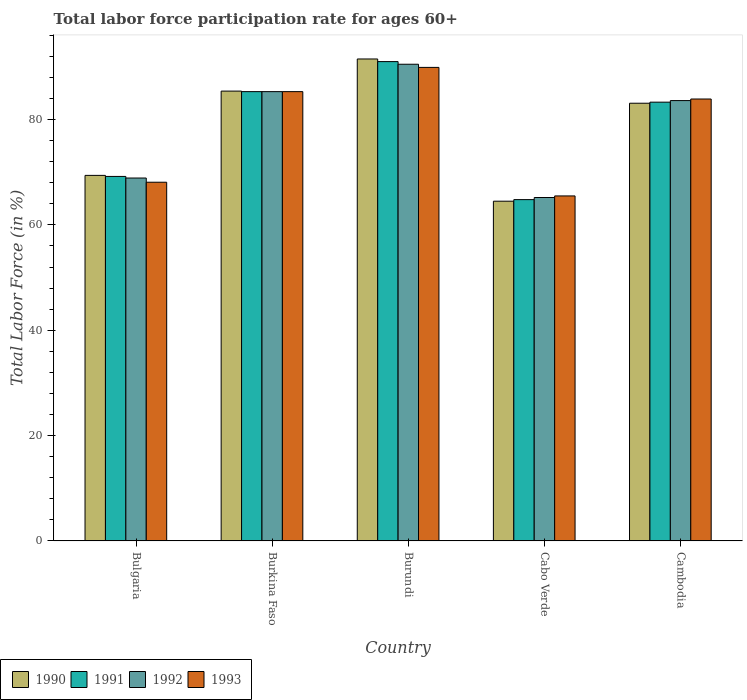How many different coloured bars are there?
Your response must be concise. 4. Are the number of bars per tick equal to the number of legend labels?
Offer a very short reply. Yes. What is the labor force participation rate in 1990 in Burundi?
Make the answer very short. 91.5. Across all countries, what is the maximum labor force participation rate in 1990?
Provide a succinct answer. 91.5. Across all countries, what is the minimum labor force participation rate in 1991?
Keep it short and to the point. 64.8. In which country was the labor force participation rate in 1991 maximum?
Your answer should be very brief. Burundi. In which country was the labor force participation rate in 1992 minimum?
Your answer should be very brief. Cabo Verde. What is the total labor force participation rate in 1992 in the graph?
Provide a short and direct response. 393.5. What is the difference between the labor force participation rate in 1993 in Bulgaria and that in Cambodia?
Provide a succinct answer. -15.8. What is the difference between the labor force participation rate in 1993 in Burkina Faso and the labor force participation rate in 1992 in Bulgaria?
Make the answer very short. 16.4. What is the average labor force participation rate in 1990 per country?
Offer a very short reply. 78.78. What is the difference between the labor force participation rate of/in 1992 and labor force participation rate of/in 1991 in Cabo Verde?
Your answer should be compact. 0.4. What is the ratio of the labor force participation rate in 1990 in Bulgaria to that in Cabo Verde?
Provide a succinct answer. 1.08. Is the labor force participation rate in 1993 in Burundi less than that in Cambodia?
Give a very brief answer. No. What is the difference between the highest and the second highest labor force participation rate in 1992?
Your answer should be compact. 6.9. What is the difference between the highest and the lowest labor force participation rate in 1991?
Provide a short and direct response. 26.2. In how many countries, is the labor force participation rate in 1990 greater than the average labor force participation rate in 1990 taken over all countries?
Your answer should be compact. 3. Is the sum of the labor force participation rate in 1993 in Burundi and Cabo Verde greater than the maximum labor force participation rate in 1990 across all countries?
Offer a terse response. Yes. Is it the case that in every country, the sum of the labor force participation rate in 1992 and labor force participation rate in 1993 is greater than the sum of labor force participation rate in 1990 and labor force participation rate in 1991?
Give a very brief answer. No. What does the 1st bar from the left in Burkina Faso represents?
Keep it short and to the point. 1990. What does the 1st bar from the right in Burundi represents?
Keep it short and to the point. 1993. Are all the bars in the graph horizontal?
Offer a terse response. No. What is the difference between two consecutive major ticks on the Y-axis?
Provide a succinct answer. 20. Does the graph contain any zero values?
Offer a very short reply. No. How many legend labels are there?
Give a very brief answer. 4. How are the legend labels stacked?
Your answer should be very brief. Horizontal. What is the title of the graph?
Provide a short and direct response. Total labor force participation rate for ages 60+. What is the label or title of the Y-axis?
Provide a short and direct response. Total Labor Force (in %). What is the Total Labor Force (in %) in 1990 in Bulgaria?
Provide a succinct answer. 69.4. What is the Total Labor Force (in %) of 1991 in Bulgaria?
Your answer should be very brief. 69.2. What is the Total Labor Force (in %) of 1992 in Bulgaria?
Make the answer very short. 68.9. What is the Total Labor Force (in %) in 1993 in Bulgaria?
Provide a short and direct response. 68.1. What is the Total Labor Force (in %) in 1990 in Burkina Faso?
Your answer should be very brief. 85.4. What is the Total Labor Force (in %) of 1991 in Burkina Faso?
Offer a terse response. 85.3. What is the Total Labor Force (in %) in 1992 in Burkina Faso?
Provide a succinct answer. 85.3. What is the Total Labor Force (in %) of 1993 in Burkina Faso?
Provide a short and direct response. 85.3. What is the Total Labor Force (in %) of 1990 in Burundi?
Provide a succinct answer. 91.5. What is the Total Labor Force (in %) in 1991 in Burundi?
Offer a terse response. 91. What is the Total Labor Force (in %) of 1992 in Burundi?
Keep it short and to the point. 90.5. What is the Total Labor Force (in %) in 1993 in Burundi?
Provide a short and direct response. 89.9. What is the Total Labor Force (in %) in 1990 in Cabo Verde?
Your response must be concise. 64.5. What is the Total Labor Force (in %) in 1991 in Cabo Verde?
Your response must be concise. 64.8. What is the Total Labor Force (in %) in 1992 in Cabo Verde?
Ensure brevity in your answer.  65.2. What is the Total Labor Force (in %) of 1993 in Cabo Verde?
Offer a terse response. 65.5. What is the Total Labor Force (in %) of 1990 in Cambodia?
Ensure brevity in your answer.  83.1. What is the Total Labor Force (in %) of 1991 in Cambodia?
Your answer should be very brief. 83.3. What is the Total Labor Force (in %) of 1992 in Cambodia?
Your response must be concise. 83.6. What is the Total Labor Force (in %) in 1993 in Cambodia?
Your response must be concise. 83.9. Across all countries, what is the maximum Total Labor Force (in %) in 1990?
Keep it short and to the point. 91.5. Across all countries, what is the maximum Total Labor Force (in %) of 1991?
Make the answer very short. 91. Across all countries, what is the maximum Total Labor Force (in %) in 1992?
Make the answer very short. 90.5. Across all countries, what is the maximum Total Labor Force (in %) in 1993?
Ensure brevity in your answer.  89.9. Across all countries, what is the minimum Total Labor Force (in %) of 1990?
Keep it short and to the point. 64.5. Across all countries, what is the minimum Total Labor Force (in %) of 1991?
Provide a succinct answer. 64.8. Across all countries, what is the minimum Total Labor Force (in %) in 1992?
Offer a very short reply. 65.2. Across all countries, what is the minimum Total Labor Force (in %) of 1993?
Offer a very short reply. 65.5. What is the total Total Labor Force (in %) in 1990 in the graph?
Provide a short and direct response. 393.9. What is the total Total Labor Force (in %) of 1991 in the graph?
Keep it short and to the point. 393.6. What is the total Total Labor Force (in %) of 1992 in the graph?
Your answer should be very brief. 393.5. What is the total Total Labor Force (in %) in 1993 in the graph?
Provide a short and direct response. 392.7. What is the difference between the Total Labor Force (in %) of 1991 in Bulgaria and that in Burkina Faso?
Your answer should be compact. -16.1. What is the difference between the Total Labor Force (in %) of 1992 in Bulgaria and that in Burkina Faso?
Ensure brevity in your answer.  -16.4. What is the difference between the Total Labor Force (in %) in 1993 in Bulgaria and that in Burkina Faso?
Your answer should be compact. -17.2. What is the difference between the Total Labor Force (in %) of 1990 in Bulgaria and that in Burundi?
Your answer should be very brief. -22.1. What is the difference between the Total Labor Force (in %) of 1991 in Bulgaria and that in Burundi?
Provide a short and direct response. -21.8. What is the difference between the Total Labor Force (in %) in 1992 in Bulgaria and that in Burundi?
Ensure brevity in your answer.  -21.6. What is the difference between the Total Labor Force (in %) of 1993 in Bulgaria and that in Burundi?
Make the answer very short. -21.8. What is the difference between the Total Labor Force (in %) of 1991 in Bulgaria and that in Cabo Verde?
Offer a terse response. 4.4. What is the difference between the Total Labor Force (in %) in 1992 in Bulgaria and that in Cabo Verde?
Give a very brief answer. 3.7. What is the difference between the Total Labor Force (in %) in 1990 in Bulgaria and that in Cambodia?
Keep it short and to the point. -13.7. What is the difference between the Total Labor Force (in %) in 1991 in Bulgaria and that in Cambodia?
Provide a succinct answer. -14.1. What is the difference between the Total Labor Force (in %) in 1992 in Bulgaria and that in Cambodia?
Provide a short and direct response. -14.7. What is the difference between the Total Labor Force (in %) in 1993 in Bulgaria and that in Cambodia?
Ensure brevity in your answer.  -15.8. What is the difference between the Total Labor Force (in %) of 1992 in Burkina Faso and that in Burundi?
Offer a very short reply. -5.2. What is the difference between the Total Labor Force (in %) of 1990 in Burkina Faso and that in Cabo Verde?
Your answer should be compact. 20.9. What is the difference between the Total Labor Force (in %) in 1991 in Burkina Faso and that in Cabo Verde?
Your answer should be compact. 20.5. What is the difference between the Total Labor Force (in %) of 1992 in Burkina Faso and that in Cabo Verde?
Your response must be concise. 20.1. What is the difference between the Total Labor Force (in %) of 1993 in Burkina Faso and that in Cabo Verde?
Your answer should be compact. 19.8. What is the difference between the Total Labor Force (in %) in 1990 in Burkina Faso and that in Cambodia?
Your answer should be very brief. 2.3. What is the difference between the Total Labor Force (in %) of 1992 in Burkina Faso and that in Cambodia?
Give a very brief answer. 1.7. What is the difference between the Total Labor Force (in %) of 1991 in Burundi and that in Cabo Verde?
Ensure brevity in your answer.  26.2. What is the difference between the Total Labor Force (in %) in 1992 in Burundi and that in Cabo Verde?
Keep it short and to the point. 25.3. What is the difference between the Total Labor Force (in %) in 1993 in Burundi and that in Cabo Verde?
Provide a short and direct response. 24.4. What is the difference between the Total Labor Force (in %) of 1990 in Burundi and that in Cambodia?
Your answer should be very brief. 8.4. What is the difference between the Total Labor Force (in %) of 1991 in Burundi and that in Cambodia?
Give a very brief answer. 7.7. What is the difference between the Total Labor Force (in %) in 1990 in Cabo Verde and that in Cambodia?
Provide a succinct answer. -18.6. What is the difference between the Total Labor Force (in %) in 1991 in Cabo Verde and that in Cambodia?
Provide a short and direct response. -18.5. What is the difference between the Total Labor Force (in %) in 1992 in Cabo Verde and that in Cambodia?
Offer a very short reply. -18.4. What is the difference between the Total Labor Force (in %) in 1993 in Cabo Verde and that in Cambodia?
Make the answer very short. -18.4. What is the difference between the Total Labor Force (in %) of 1990 in Bulgaria and the Total Labor Force (in %) of 1991 in Burkina Faso?
Offer a terse response. -15.9. What is the difference between the Total Labor Force (in %) in 1990 in Bulgaria and the Total Labor Force (in %) in 1992 in Burkina Faso?
Make the answer very short. -15.9. What is the difference between the Total Labor Force (in %) of 1990 in Bulgaria and the Total Labor Force (in %) of 1993 in Burkina Faso?
Provide a succinct answer. -15.9. What is the difference between the Total Labor Force (in %) in 1991 in Bulgaria and the Total Labor Force (in %) in 1992 in Burkina Faso?
Make the answer very short. -16.1. What is the difference between the Total Labor Force (in %) in 1991 in Bulgaria and the Total Labor Force (in %) in 1993 in Burkina Faso?
Provide a succinct answer. -16.1. What is the difference between the Total Labor Force (in %) in 1992 in Bulgaria and the Total Labor Force (in %) in 1993 in Burkina Faso?
Keep it short and to the point. -16.4. What is the difference between the Total Labor Force (in %) in 1990 in Bulgaria and the Total Labor Force (in %) in 1991 in Burundi?
Keep it short and to the point. -21.6. What is the difference between the Total Labor Force (in %) of 1990 in Bulgaria and the Total Labor Force (in %) of 1992 in Burundi?
Offer a very short reply. -21.1. What is the difference between the Total Labor Force (in %) in 1990 in Bulgaria and the Total Labor Force (in %) in 1993 in Burundi?
Provide a short and direct response. -20.5. What is the difference between the Total Labor Force (in %) of 1991 in Bulgaria and the Total Labor Force (in %) of 1992 in Burundi?
Ensure brevity in your answer.  -21.3. What is the difference between the Total Labor Force (in %) of 1991 in Bulgaria and the Total Labor Force (in %) of 1993 in Burundi?
Ensure brevity in your answer.  -20.7. What is the difference between the Total Labor Force (in %) in 1990 in Bulgaria and the Total Labor Force (in %) in 1991 in Cabo Verde?
Your answer should be compact. 4.6. What is the difference between the Total Labor Force (in %) in 1990 in Bulgaria and the Total Labor Force (in %) in 1992 in Cabo Verde?
Your answer should be compact. 4.2. What is the difference between the Total Labor Force (in %) of 1991 in Bulgaria and the Total Labor Force (in %) of 1992 in Cabo Verde?
Give a very brief answer. 4. What is the difference between the Total Labor Force (in %) of 1991 in Bulgaria and the Total Labor Force (in %) of 1993 in Cabo Verde?
Offer a very short reply. 3.7. What is the difference between the Total Labor Force (in %) of 1991 in Bulgaria and the Total Labor Force (in %) of 1992 in Cambodia?
Make the answer very short. -14.4. What is the difference between the Total Labor Force (in %) in 1991 in Bulgaria and the Total Labor Force (in %) in 1993 in Cambodia?
Provide a short and direct response. -14.7. What is the difference between the Total Labor Force (in %) of 1990 in Burkina Faso and the Total Labor Force (in %) of 1992 in Burundi?
Your answer should be very brief. -5.1. What is the difference between the Total Labor Force (in %) of 1990 in Burkina Faso and the Total Labor Force (in %) of 1991 in Cabo Verde?
Keep it short and to the point. 20.6. What is the difference between the Total Labor Force (in %) of 1990 in Burkina Faso and the Total Labor Force (in %) of 1992 in Cabo Verde?
Ensure brevity in your answer.  20.2. What is the difference between the Total Labor Force (in %) in 1990 in Burkina Faso and the Total Labor Force (in %) in 1993 in Cabo Verde?
Your response must be concise. 19.9. What is the difference between the Total Labor Force (in %) of 1991 in Burkina Faso and the Total Labor Force (in %) of 1992 in Cabo Verde?
Provide a succinct answer. 20.1. What is the difference between the Total Labor Force (in %) of 1991 in Burkina Faso and the Total Labor Force (in %) of 1993 in Cabo Verde?
Your response must be concise. 19.8. What is the difference between the Total Labor Force (in %) in 1992 in Burkina Faso and the Total Labor Force (in %) in 1993 in Cabo Verde?
Make the answer very short. 19.8. What is the difference between the Total Labor Force (in %) of 1990 in Burkina Faso and the Total Labor Force (in %) of 1991 in Cambodia?
Your answer should be compact. 2.1. What is the difference between the Total Labor Force (in %) in 1990 in Burkina Faso and the Total Labor Force (in %) in 1993 in Cambodia?
Keep it short and to the point. 1.5. What is the difference between the Total Labor Force (in %) of 1991 in Burkina Faso and the Total Labor Force (in %) of 1992 in Cambodia?
Offer a terse response. 1.7. What is the difference between the Total Labor Force (in %) in 1990 in Burundi and the Total Labor Force (in %) in 1991 in Cabo Verde?
Ensure brevity in your answer.  26.7. What is the difference between the Total Labor Force (in %) in 1990 in Burundi and the Total Labor Force (in %) in 1992 in Cabo Verde?
Make the answer very short. 26.3. What is the difference between the Total Labor Force (in %) in 1990 in Burundi and the Total Labor Force (in %) in 1993 in Cabo Verde?
Provide a succinct answer. 26. What is the difference between the Total Labor Force (in %) of 1991 in Burundi and the Total Labor Force (in %) of 1992 in Cabo Verde?
Provide a short and direct response. 25.8. What is the difference between the Total Labor Force (in %) in 1992 in Burundi and the Total Labor Force (in %) in 1993 in Cabo Verde?
Your answer should be compact. 25. What is the difference between the Total Labor Force (in %) in 1990 in Burundi and the Total Labor Force (in %) in 1991 in Cambodia?
Offer a terse response. 8.2. What is the difference between the Total Labor Force (in %) of 1990 in Burundi and the Total Labor Force (in %) of 1992 in Cambodia?
Offer a very short reply. 7.9. What is the difference between the Total Labor Force (in %) of 1991 in Burundi and the Total Labor Force (in %) of 1993 in Cambodia?
Offer a terse response. 7.1. What is the difference between the Total Labor Force (in %) in 1992 in Burundi and the Total Labor Force (in %) in 1993 in Cambodia?
Your answer should be very brief. 6.6. What is the difference between the Total Labor Force (in %) in 1990 in Cabo Verde and the Total Labor Force (in %) in 1991 in Cambodia?
Offer a very short reply. -18.8. What is the difference between the Total Labor Force (in %) of 1990 in Cabo Verde and the Total Labor Force (in %) of 1992 in Cambodia?
Keep it short and to the point. -19.1. What is the difference between the Total Labor Force (in %) in 1990 in Cabo Verde and the Total Labor Force (in %) in 1993 in Cambodia?
Your answer should be very brief. -19.4. What is the difference between the Total Labor Force (in %) of 1991 in Cabo Verde and the Total Labor Force (in %) of 1992 in Cambodia?
Your answer should be compact. -18.8. What is the difference between the Total Labor Force (in %) in 1991 in Cabo Verde and the Total Labor Force (in %) in 1993 in Cambodia?
Give a very brief answer. -19.1. What is the difference between the Total Labor Force (in %) in 1992 in Cabo Verde and the Total Labor Force (in %) in 1993 in Cambodia?
Your answer should be very brief. -18.7. What is the average Total Labor Force (in %) in 1990 per country?
Your answer should be compact. 78.78. What is the average Total Labor Force (in %) in 1991 per country?
Your answer should be compact. 78.72. What is the average Total Labor Force (in %) in 1992 per country?
Your answer should be compact. 78.7. What is the average Total Labor Force (in %) in 1993 per country?
Your response must be concise. 78.54. What is the difference between the Total Labor Force (in %) of 1990 and Total Labor Force (in %) of 1993 in Bulgaria?
Make the answer very short. 1.3. What is the difference between the Total Labor Force (in %) in 1991 and Total Labor Force (in %) in 1992 in Bulgaria?
Your response must be concise. 0.3. What is the difference between the Total Labor Force (in %) of 1991 and Total Labor Force (in %) of 1992 in Burkina Faso?
Ensure brevity in your answer.  0. What is the difference between the Total Labor Force (in %) in 1990 and Total Labor Force (in %) in 1991 in Burundi?
Ensure brevity in your answer.  0.5. What is the difference between the Total Labor Force (in %) of 1990 and Total Labor Force (in %) of 1993 in Burundi?
Offer a very short reply. 1.6. What is the difference between the Total Labor Force (in %) in 1990 and Total Labor Force (in %) in 1991 in Cabo Verde?
Give a very brief answer. -0.3. What is the difference between the Total Labor Force (in %) of 1990 and Total Labor Force (in %) of 1993 in Cabo Verde?
Your response must be concise. -1. What is the difference between the Total Labor Force (in %) of 1990 and Total Labor Force (in %) of 1991 in Cambodia?
Your response must be concise. -0.2. What is the difference between the Total Labor Force (in %) in 1991 and Total Labor Force (in %) in 1993 in Cambodia?
Offer a very short reply. -0.6. What is the ratio of the Total Labor Force (in %) of 1990 in Bulgaria to that in Burkina Faso?
Make the answer very short. 0.81. What is the ratio of the Total Labor Force (in %) in 1991 in Bulgaria to that in Burkina Faso?
Your response must be concise. 0.81. What is the ratio of the Total Labor Force (in %) of 1992 in Bulgaria to that in Burkina Faso?
Make the answer very short. 0.81. What is the ratio of the Total Labor Force (in %) of 1993 in Bulgaria to that in Burkina Faso?
Ensure brevity in your answer.  0.8. What is the ratio of the Total Labor Force (in %) of 1990 in Bulgaria to that in Burundi?
Ensure brevity in your answer.  0.76. What is the ratio of the Total Labor Force (in %) of 1991 in Bulgaria to that in Burundi?
Your response must be concise. 0.76. What is the ratio of the Total Labor Force (in %) in 1992 in Bulgaria to that in Burundi?
Offer a terse response. 0.76. What is the ratio of the Total Labor Force (in %) in 1993 in Bulgaria to that in Burundi?
Ensure brevity in your answer.  0.76. What is the ratio of the Total Labor Force (in %) of 1990 in Bulgaria to that in Cabo Verde?
Offer a terse response. 1.08. What is the ratio of the Total Labor Force (in %) of 1991 in Bulgaria to that in Cabo Verde?
Keep it short and to the point. 1.07. What is the ratio of the Total Labor Force (in %) of 1992 in Bulgaria to that in Cabo Verde?
Offer a terse response. 1.06. What is the ratio of the Total Labor Force (in %) in 1993 in Bulgaria to that in Cabo Verde?
Your answer should be very brief. 1.04. What is the ratio of the Total Labor Force (in %) in 1990 in Bulgaria to that in Cambodia?
Keep it short and to the point. 0.84. What is the ratio of the Total Labor Force (in %) in 1991 in Bulgaria to that in Cambodia?
Offer a very short reply. 0.83. What is the ratio of the Total Labor Force (in %) in 1992 in Bulgaria to that in Cambodia?
Give a very brief answer. 0.82. What is the ratio of the Total Labor Force (in %) of 1993 in Bulgaria to that in Cambodia?
Your response must be concise. 0.81. What is the ratio of the Total Labor Force (in %) of 1991 in Burkina Faso to that in Burundi?
Your response must be concise. 0.94. What is the ratio of the Total Labor Force (in %) of 1992 in Burkina Faso to that in Burundi?
Ensure brevity in your answer.  0.94. What is the ratio of the Total Labor Force (in %) of 1993 in Burkina Faso to that in Burundi?
Your answer should be compact. 0.95. What is the ratio of the Total Labor Force (in %) in 1990 in Burkina Faso to that in Cabo Verde?
Provide a short and direct response. 1.32. What is the ratio of the Total Labor Force (in %) in 1991 in Burkina Faso to that in Cabo Verde?
Offer a very short reply. 1.32. What is the ratio of the Total Labor Force (in %) of 1992 in Burkina Faso to that in Cabo Verde?
Keep it short and to the point. 1.31. What is the ratio of the Total Labor Force (in %) of 1993 in Burkina Faso to that in Cabo Verde?
Your response must be concise. 1.3. What is the ratio of the Total Labor Force (in %) of 1990 in Burkina Faso to that in Cambodia?
Provide a succinct answer. 1.03. What is the ratio of the Total Labor Force (in %) in 1991 in Burkina Faso to that in Cambodia?
Your answer should be compact. 1.02. What is the ratio of the Total Labor Force (in %) of 1992 in Burkina Faso to that in Cambodia?
Your answer should be compact. 1.02. What is the ratio of the Total Labor Force (in %) of 1993 in Burkina Faso to that in Cambodia?
Your response must be concise. 1.02. What is the ratio of the Total Labor Force (in %) of 1990 in Burundi to that in Cabo Verde?
Your answer should be compact. 1.42. What is the ratio of the Total Labor Force (in %) in 1991 in Burundi to that in Cabo Verde?
Ensure brevity in your answer.  1.4. What is the ratio of the Total Labor Force (in %) of 1992 in Burundi to that in Cabo Verde?
Make the answer very short. 1.39. What is the ratio of the Total Labor Force (in %) in 1993 in Burundi to that in Cabo Verde?
Give a very brief answer. 1.37. What is the ratio of the Total Labor Force (in %) of 1990 in Burundi to that in Cambodia?
Keep it short and to the point. 1.1. What is the ratio of the Total Labor Force (in %) in 1991 in Burundi to that in Cambodia?
Offer a very short reply. 1.09. What is the ratio of the Total Labor Force (in %) in 1992 in Burundi to that in Cambodia?
Give a very brief answer. 1.08. What is the ratio of the Total Labor Force (in %) in 1993 in Burundi to that in Cambodia?
Offer a terse response. 1.07. What is the ratio of the Total Labor Force (in %) of 1990 in Cabo Verde to that in Cambodia?
Keep it short and to the point. 0.78. What is the ratio of the Total Labor Force (in %) in 1991 in Cabo Verde to that in Cambodia?
Your answer should be compact. 0.78. What is the ratio of the Total Labor Force (in %) of 1992 in Cabo Verde to that in Cambodia?
Your answer should be compact. 0.78. What is the ratio of the Total Labor Force (in %) of 1993 in Cabo Verde to that in Cambodia?
Offer a terse response. 0.78. What is the difference between the highest and the second highest Total Labor Force (in %) in 1990?
Make the answer very short. 6.1. What is the difference between the highest and the second highest Total Labor Force (in %) of 1992?
Your answer should be very brief. 5.2. What is the difference between the highest and the second highest Total Labor Force (in %) in 1993?
Offer a terse response. 4.6. What is the difference between the highest and the lowest Total Labor Force (in %) of 1991?
Ensure brevity in your answer.  26.2. What is the difference between the highest and the lowest Total Labor Force (in %) in 1992?
Ensure brevity in your answer.  25.3. What is the difference between the highest and the lowest Total Labor Force (in %) in 1993?
Give a very brief answer. 24.4. 